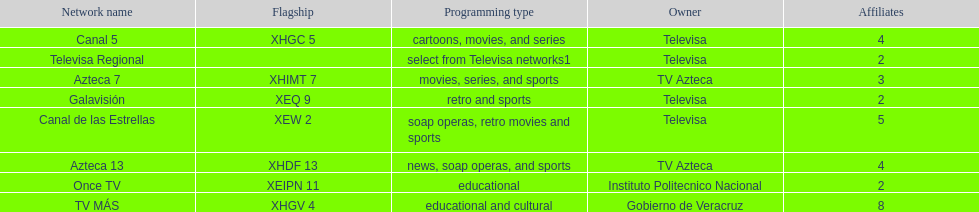Which owner has the most networks? Televisa. 